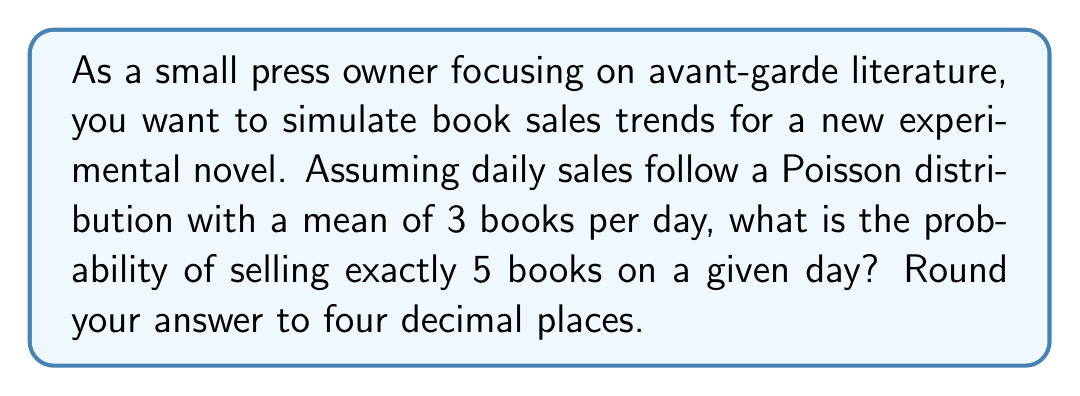Provide a solution to this math problem. To solve this problem, we'll use the Poisson distribution formula:

$$P(X = k) = \frac{e^{-\lambda} \lambda^k}{k!}$$

Where:
$P(X = k)$ is the probability of $k$ events occurring
$\lambda$ is the average number of events per interval
$e$ is Euler's number (approximately 2.71828)
$k$ is the number of events we're calculating the probability for

Given:
$\lambda = 3$ (mean of 3 books sold per day)
$k = 5$ (we want the probability of selling exactly 5 books)

Step 1: Plug the values into the formula
$$P(X = 5) = \frac{e^{-3} 3^5}{5!}$$

Step 2: Calculate $e^{-3}$
$e^{-3} \approx 0.0497871$

Step 3: Calculate $3^5$
$3^5 = 243$

Step 4: Calculate $5!$
$5! = 5 \times 4 \times 3 \times 2 \times 1 = 120$

Step 5: Put it all together
$$P(X = 5) = \frac{0.0497871 \times 243}{120}$$

Step 6: Perform the calculation
$$P(X = 5) = 0.1008467$$

Step 7: Round to four decimal places
$$P(X = 5) \approx 0.1008$$
Answer: 0.1008 